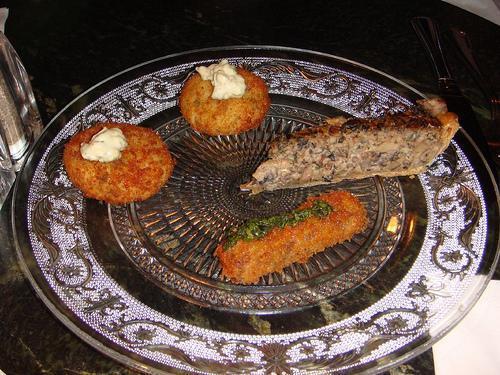How many people are standing on the floor?
Give a very brief answer. 0. 